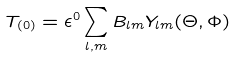<formula> <loc_0><loc_0><loc_500><loc_500>T _ { ( 0 ) } = \epsilon ^ { 0 } \sum _ { l , m } B _ { l m } Y _ { l m } ( \Theta , \Phi )</formula> 